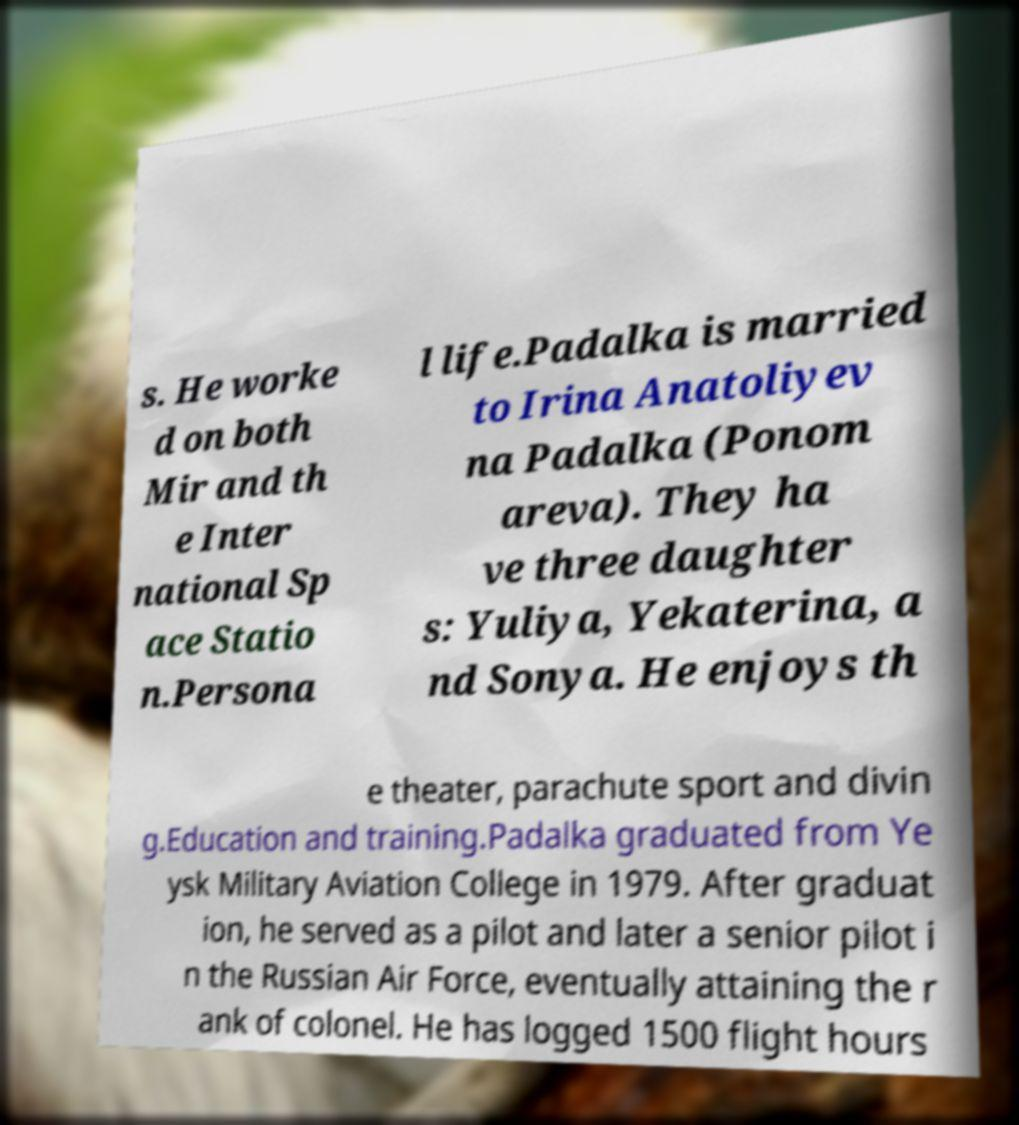There's text embedded in this image that I need extracted. Can you transcribe it verbatim? s. He worke d on both Mir and th e Inter national Sp ace Statio n.Persona l life.Padalka is married to Irina Anatoliyev na Padalka (Ponom areva). They ha ve three daughter s: Yuliya, Yekaterina, a nd Sonya. He enjoys th e theater, parachute sport and divin g.Education and training.Padalka graduated from Ye ysk Military Aviation College in 1979. After graduat ion, he served as a pilot and later a senior pilot i n the Russian Air Force, eventually attaining the r ank of colonel. He has logged 1500 flight hours 